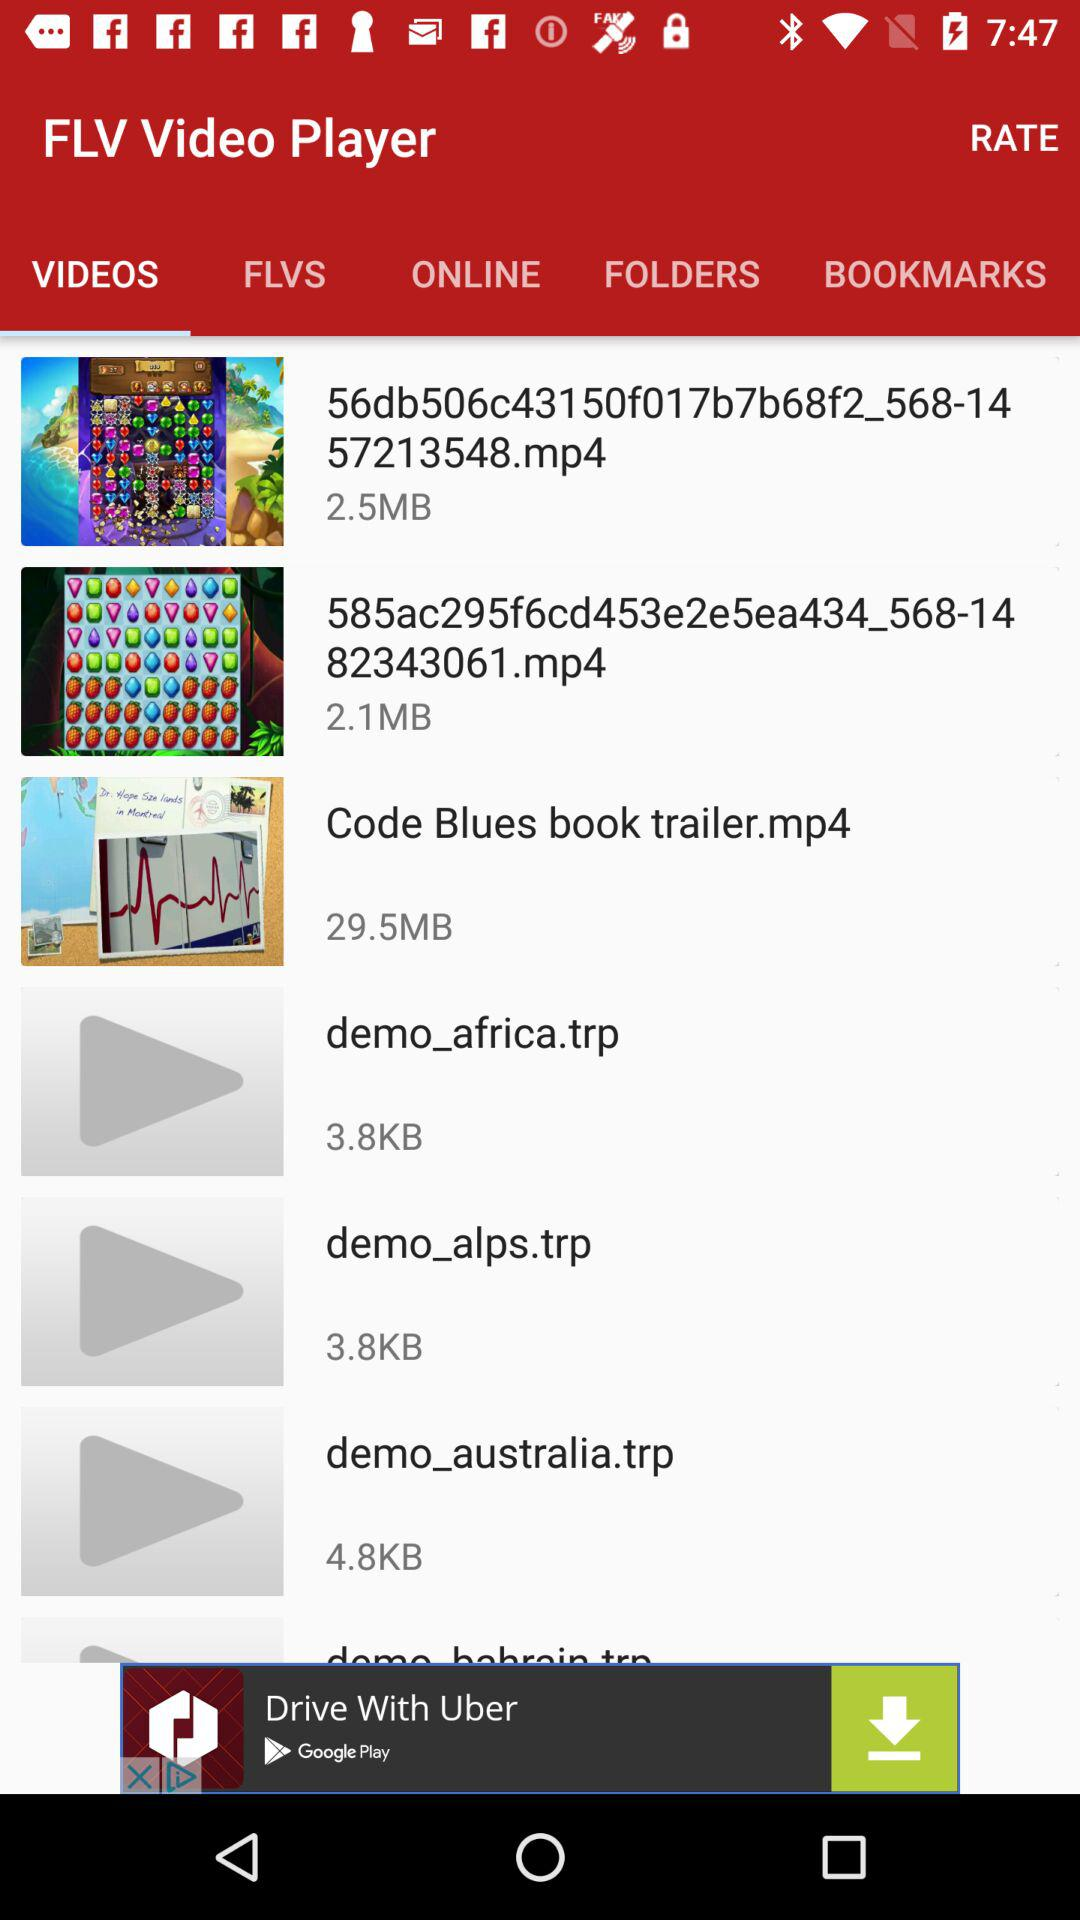What is the size of "demo_africa.trp"? The size is 3.8 KB. 